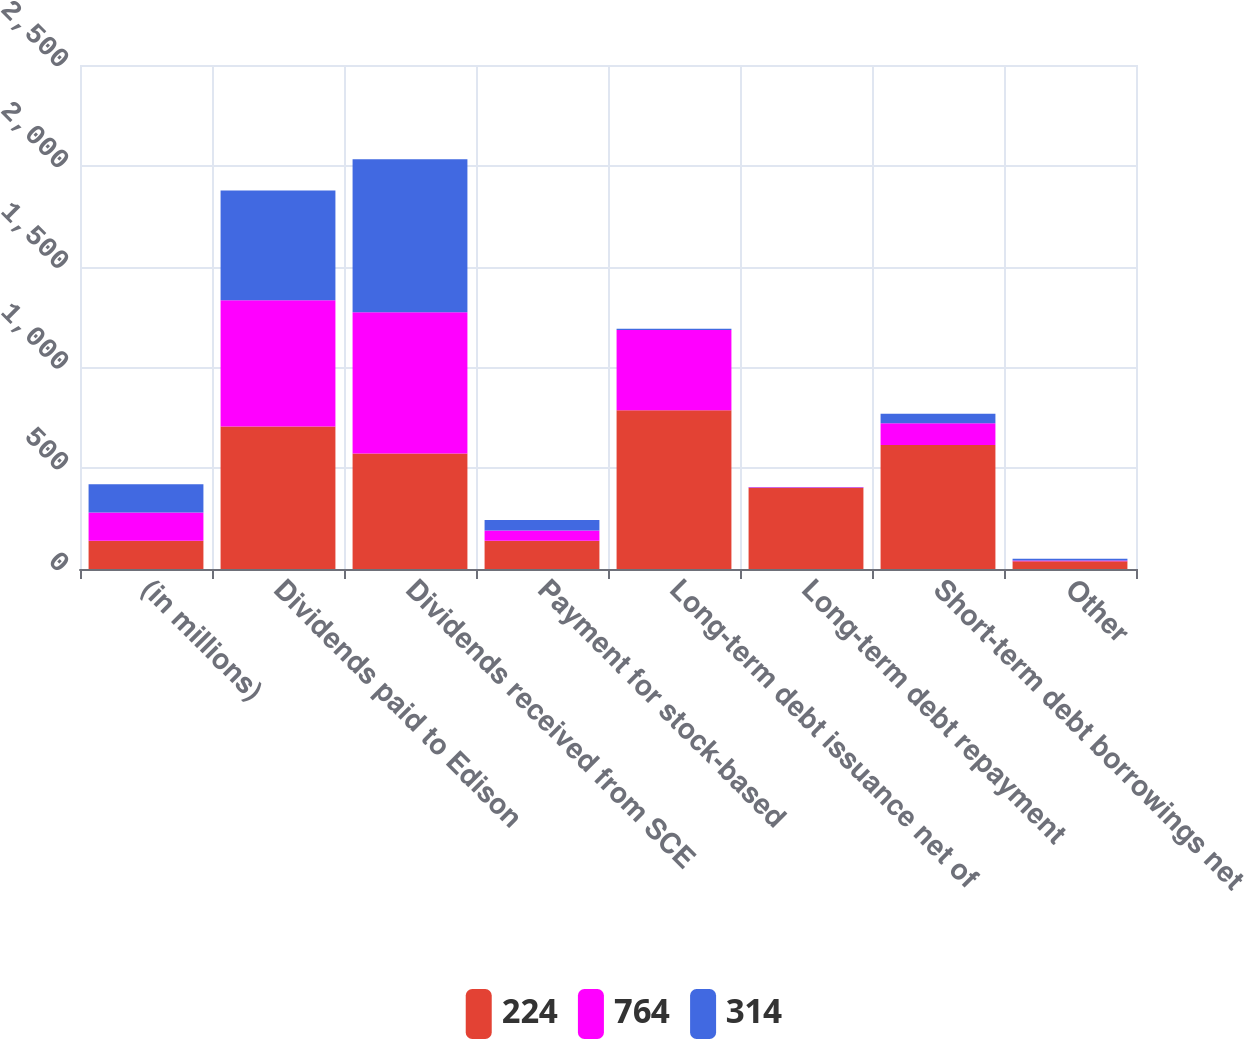Convert chart. <chart><loc_0><loc_0><loc_500><loc_500><stacked_bar_chart><ecel><fcel>(in millions)<fcel>Dividends paid to Edison<fcel>Dividends received from SCE<fcel>Payment for stock-based<fcel>Long-term debt issuance net of<fcel>Long-term debt repayment<fcel>Short-term debt borrowings net<fcel>Other<nl><fcel>224<fcel>140<fcel>707<fcel>573<fcel>140<fcel>788<fcel>403<fcel>615<fcel>38<nl><fcel>764<fcel>140<fcel>626<fcel>701<fcel>51<fcel>397<fcel>3<fcel>108<fcel>4<nl><fcel>314<fcel>140<fcel>544<fcel>758<fcel>52<fcel>7<fcel>1<fcel>47<fcel>9<nl></chart> 